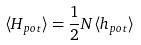<formula> <loc_0><loc_0><loc_500><loc_500>\langle H _ { p o t } \rangle = \frac { 1 } { 2 } N \langle h _ { p o t } \rangle</formula> 